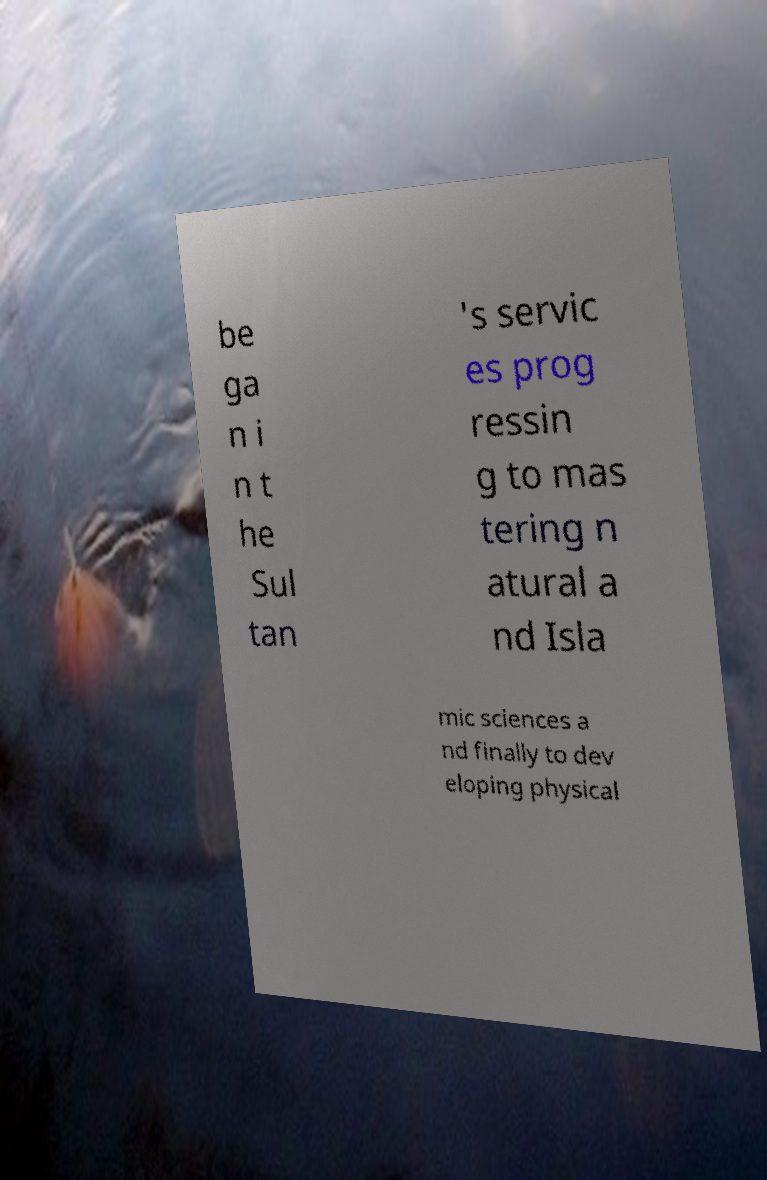Could you extract and type out the text from this image? be ga n i n t he Sul tan 's servic es prog ressin g to mas tering n atural a nd Isla mic sciences a nd finally to dev eloping physical 